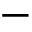<formula> <loc_0><loc_0><loc_500><loc_500>-</formula> 